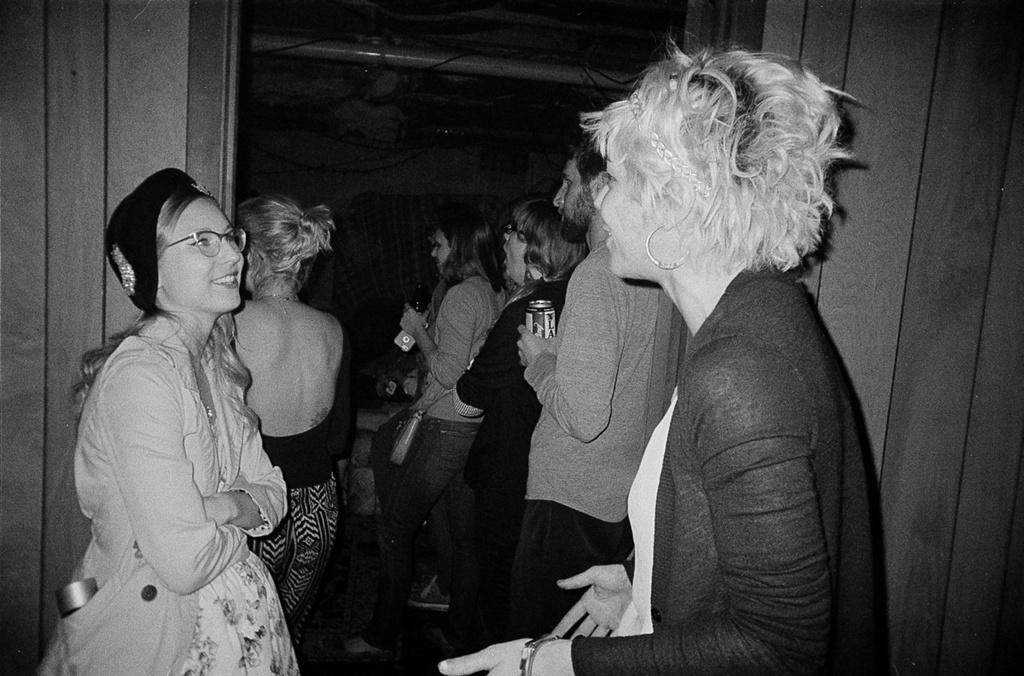What is the color scheme of the image? The image is black and white. What can be seen in the foreground of the image? There are two people standing in front of a door. What is happening inside the door? There are other people inside the door. Can you describe any specific detail about one of the people inside the door? One of the people inside the door is holding a coke tin in his hand. How many fowls are visible in the image? There are no fowls present in the image. What is the limit of the door in the image? The image does not provide information about the limit of the door. 